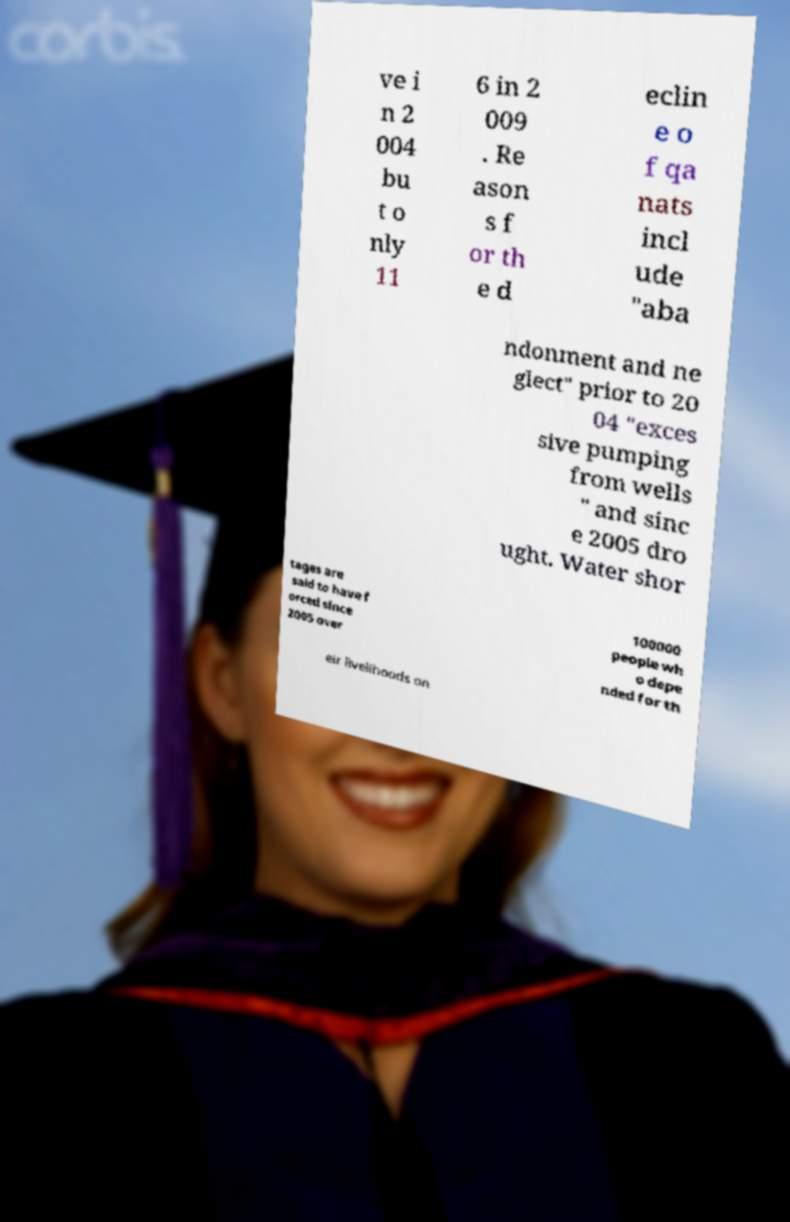Please read and relay the text visible in this image. What does it say? ve i n 2 004 bu t o nly 11 6 in 2 009 . Re ason s f or th e d eclin e o f qa nats incl ude "aba ndonment and ne glect" prior to 20 04 "exces sive pumping from wells " and sinc e 2005 dro ught. Water shor tages are said to have f orced since 2005 over 100000 people wh o depe nded for th eir livelihoods on 